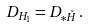<formula> <loc_0><loc_0><loc_500><loc_500>D _ { H _ { 1 } } = D _ { \ast \check { H } } \, .</formula> 